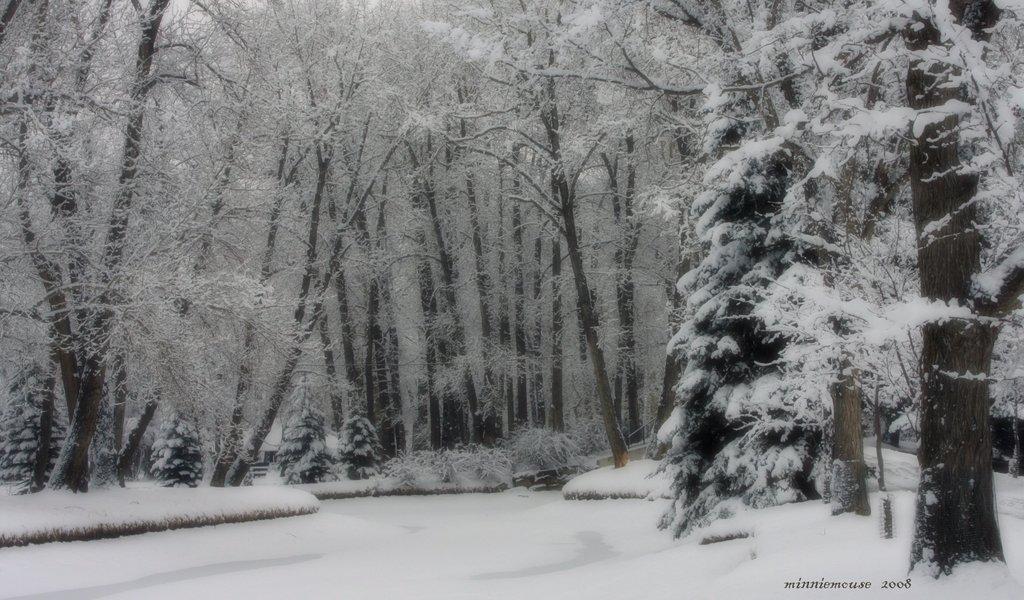Describe this image in one or two sentences. In this picture we can see snow and few trees, in the bottom right hand corner we can see some text. 